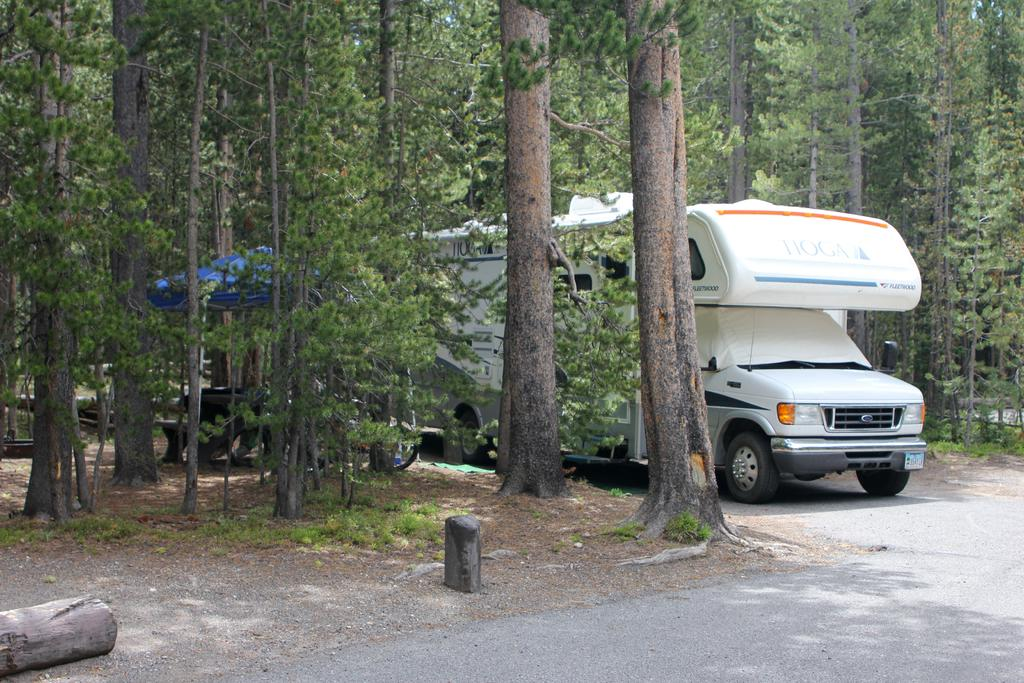What is the main subject of the image? The main subject of the image is a caravan on the road. Can you describe the location of the caravan in the image? The caravan is on the road surface. What type of vegetation can be seen on either side of the road in the image? There are trees on either side of the road in the image. What type of whip can be seen being used by the driver of the caravan in the image? There is no whip present in the image, nor is there any indication of a driver. What type of profit can be seen being generated by the caravan in the image? There is no indication of profit generation in the image; it simply shows a caravan on the road. 